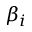Convert formula to latex. <formula><loc_0><loc_0><loc_500><loc_500>\beta _ { i }</formula> 